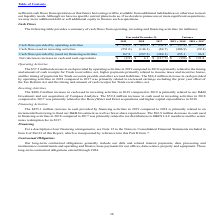According to Black Knight Financial Services's financial document, What was the change in operating activities between 2018 and 2019? According to the financial document, (57.2) (in millions). The relevant text states: "by operating activities $ 378.3 $ 435.5 $ 351.1 $ (57.2) $ 84.4..." Also, What was the change in operating activities between 2017 and 2018?  According to the financial document, 84.4 (in millions). The relevant text states: "ing activities $ 378.3 $ 435.5 $ 351.1 $ (57.2) $ 84.4..." Also, Why did investing activities increase between 2017 and 2018? primarily related to the HeavyWater and Ernst acquisitions and higher capital expenditures in 2018.. The document states: "investing activities in 2018 compared to 2017 was primarily related to the HeavyWater and Ernst acquisitions and higher capital expenditures in 2018...." Also, can you calculate: What was the cash flows provided by operating activities in 2019 as a percentage of the cash flow in 2018? Based on the calculation: 378.3/435.5, the result is 86.87 (percentage). This is based on the information: "flows provided by operating activities $ 378.3 $ 435.5 $ 351.1 $ (57.2) $ 84.4 Cash flows provided by operating activities $ 378.3 $ 435.5 $ 351.1 $ (57.2) $ 84.4..." The key data points involved are: 378.3, 435.5. Also, How many years was the Net  increase in cash and cash equivalents positive? Based on the analysis, there are 1 instances. The counting process: 2018. Also, can you calculate: What was the percentage change in Cash flows provided by operating activities between 2018 and 2019? To answer this question, I need to perform calculations using the financial data. The calculation is: (378.3-435.5)/435.5, which equals -13.13 (percentage). This is based on the information: "flows provided by operating activities $ 378.3 $ 435.5 $ 351.1 $ (57.2) $ 84.4 Cash flows provided by operating activities $ 378.3 $ 435.5 $ 351.1 $ (57.2) $ 84.4..." The key data points involved are: 378.3, 435.5. 